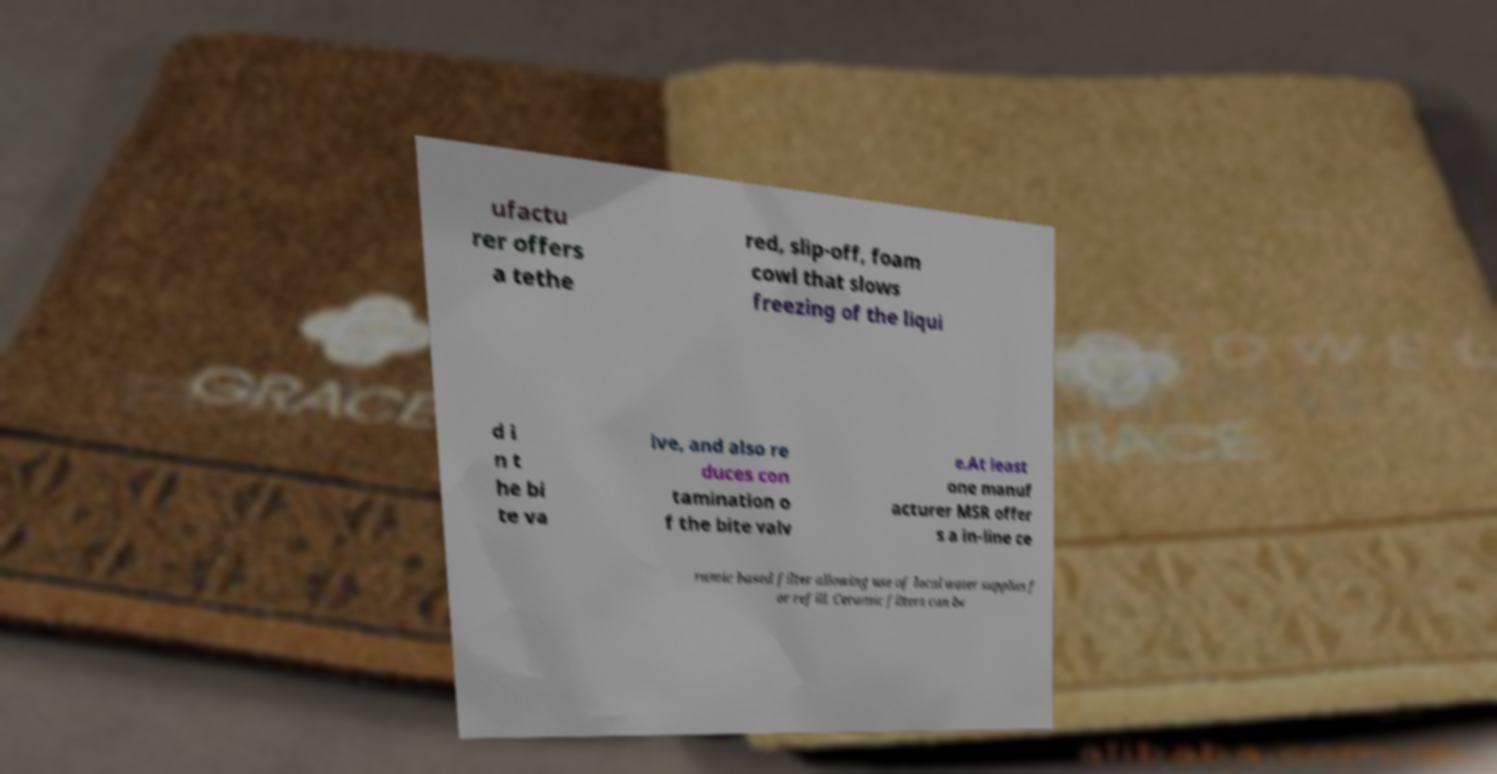What messages or text are displayed in this image? I need them in a readable, typed format. ufactu rer offers a tethe red, slip-off, foam cowl that slows freezing of the liqui d i n t he bi te va lve, and also re duces con tamination o f the bite valv e.At least one manuf acturer MSR offer s a in-line ce ramic based filter allowing use of local water supplies f or refill. Ceramic filters can be 